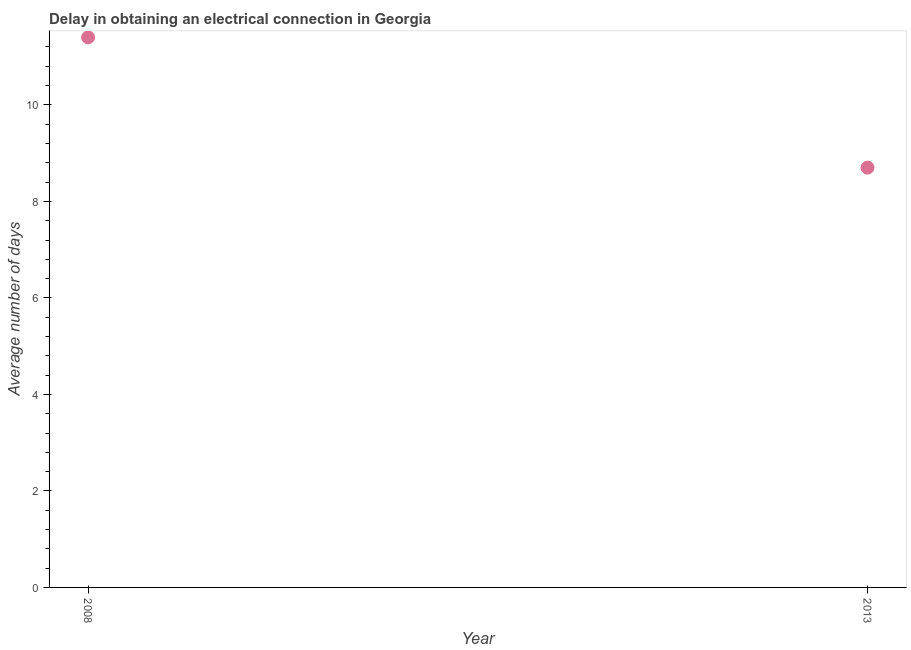Across all years, what is the minimum dalay in electrical connection?
Ensure brevity in your answer.  8.7. In which year was the dalay in electrical connection maximum?
Your answer should be compact. 2008. In which year was the dalay in electrical connection minimum?
Keep it short and to the point. 2013. What is the sum of the dalay in electrical connection?
Keep it short and to the point. 20.1. What is the difference between the dalay in electrical connection in 2008 and 2013?
Ensure brevity in your answer.  2.7. What is the average dalay in electrical connection per year?
Ensure brevity in your answer.  10.05. What is the median dalay in electrical connection?
Offer a very short reply. 10.05. What is the ratio of the dalay in electrical connection in 2008 to that in 2013?
Offer a very short reply. 1.31. In how many years, is the dalay in electrical connection greater than the average dalay in electrical connection taken over all years?
Your answer should be compact. 1. Does the dalay in electrical connection monotonically increase over the years?
Your answer should be compact. No. How many dotlines are there?
Provide a succinct answer. 1. How many years are there in the graph?
Your response must be concise. 2. Are the values on the major ticks of Y-axis written in scientific E-notation?
Your response must be concise. No. Does the graph contain any zero values?
Your answer should be very brief. No. Does the graph contain grids?
Give a very brief answer. No. What is the title of the graph?
Your answer should be very brief. Delay in obtaining an electrical connection in Georgia. What is the label or title of the X-axis?
Offer a terse response. Year. What is the label or title of the Y-axis?
Make the answer very short. Average number of days. What is the Average number of days in 2013?
Your answer should be very brief. 8.7. What is the difference between the Average number of days in 2008 and 2013?
Make the answer very short. 2.7. What is the ratio of the Average number of days in 2008 to that in 2013?
Your answer should be compact. 1.31. 